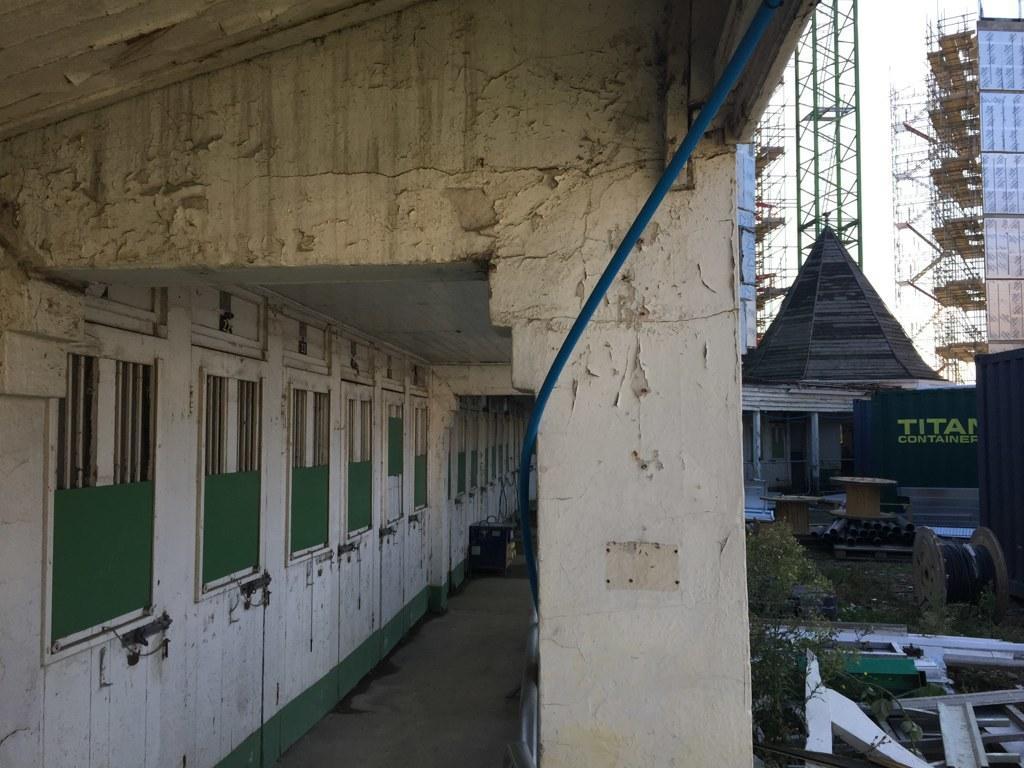Can you describe this image briefly? In this picture I can see there is a building and it has several doors here with windows and there is a pillar on to right. In the backdrop I can find few plants and there are few buildings in construction and the sky is clear. 